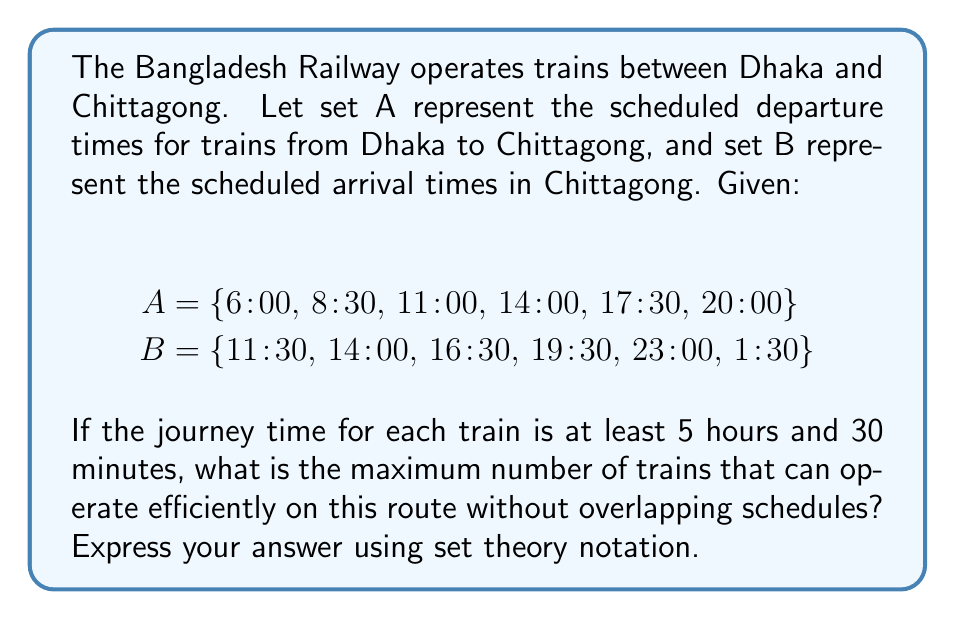Give your solution to this math problem. To solve this problem, we need to analyze the relationship between the departure and arrival times using set theory concepts.

1. First, let's create a set C that represents the possible journey durations:
   C = {5:30, 5:30, 5:30, 5:30, 5:30, 5:30}

2. Now, we need to create a set of ordered pairs (a, b) where a ∈ A and b ∈ B, such that b - a ≥ 5:30. This set represents all possible efficient train schedules:

   D = {(a, b) | a ∈ A, b ∈ B, b - a ≥ 5:30}

3. Let's determine the elements of set D:
   (6:00, 11:30), (6:00, 14:00), (6:00, 16:30), (6:00, 19:30), (6:00, 23:00), (6:00, 1:30)
   (8:30, 14:00), (8:30, 16:30), (8:30, 19:30), (8:30, 23:00), (8:30, 1:30)
   (11:00, 16:30), (11:00, 19:30), (11:00, 23:00), (11:00, 1:30)
   (14:00, 19:30), (14:00, 23:00), (14:00, 1:30)
   (17:30, 23:00), (17:30, 1:30)
   (20:00, 1:30)

4. To find the maximum number of trains that can operate efficiently without overlapping schedules, we need to find the largest subset E of D where no two pairs in E share the same first or second component.

5. The largest such subset is:
   E = {(6:00, 11:30), (8:30, 14:00), (11:00, 16:30), (14:00, 19:30), (17:30, 23:00), (20:00, 1:30)}

6. The cardinality of set E represents the maximum number of trains that can operate efficiently:
   |E| = 6
Answer: The maximum number of trains that can operate efficiently on this route without overlapping schedules is |E| = 6, where E is the largest subset of D = {(a, b) | a ∈ A, b ∈ B, b - a ≥ 5:30} such that no two pairs in E share the same first or second component. 